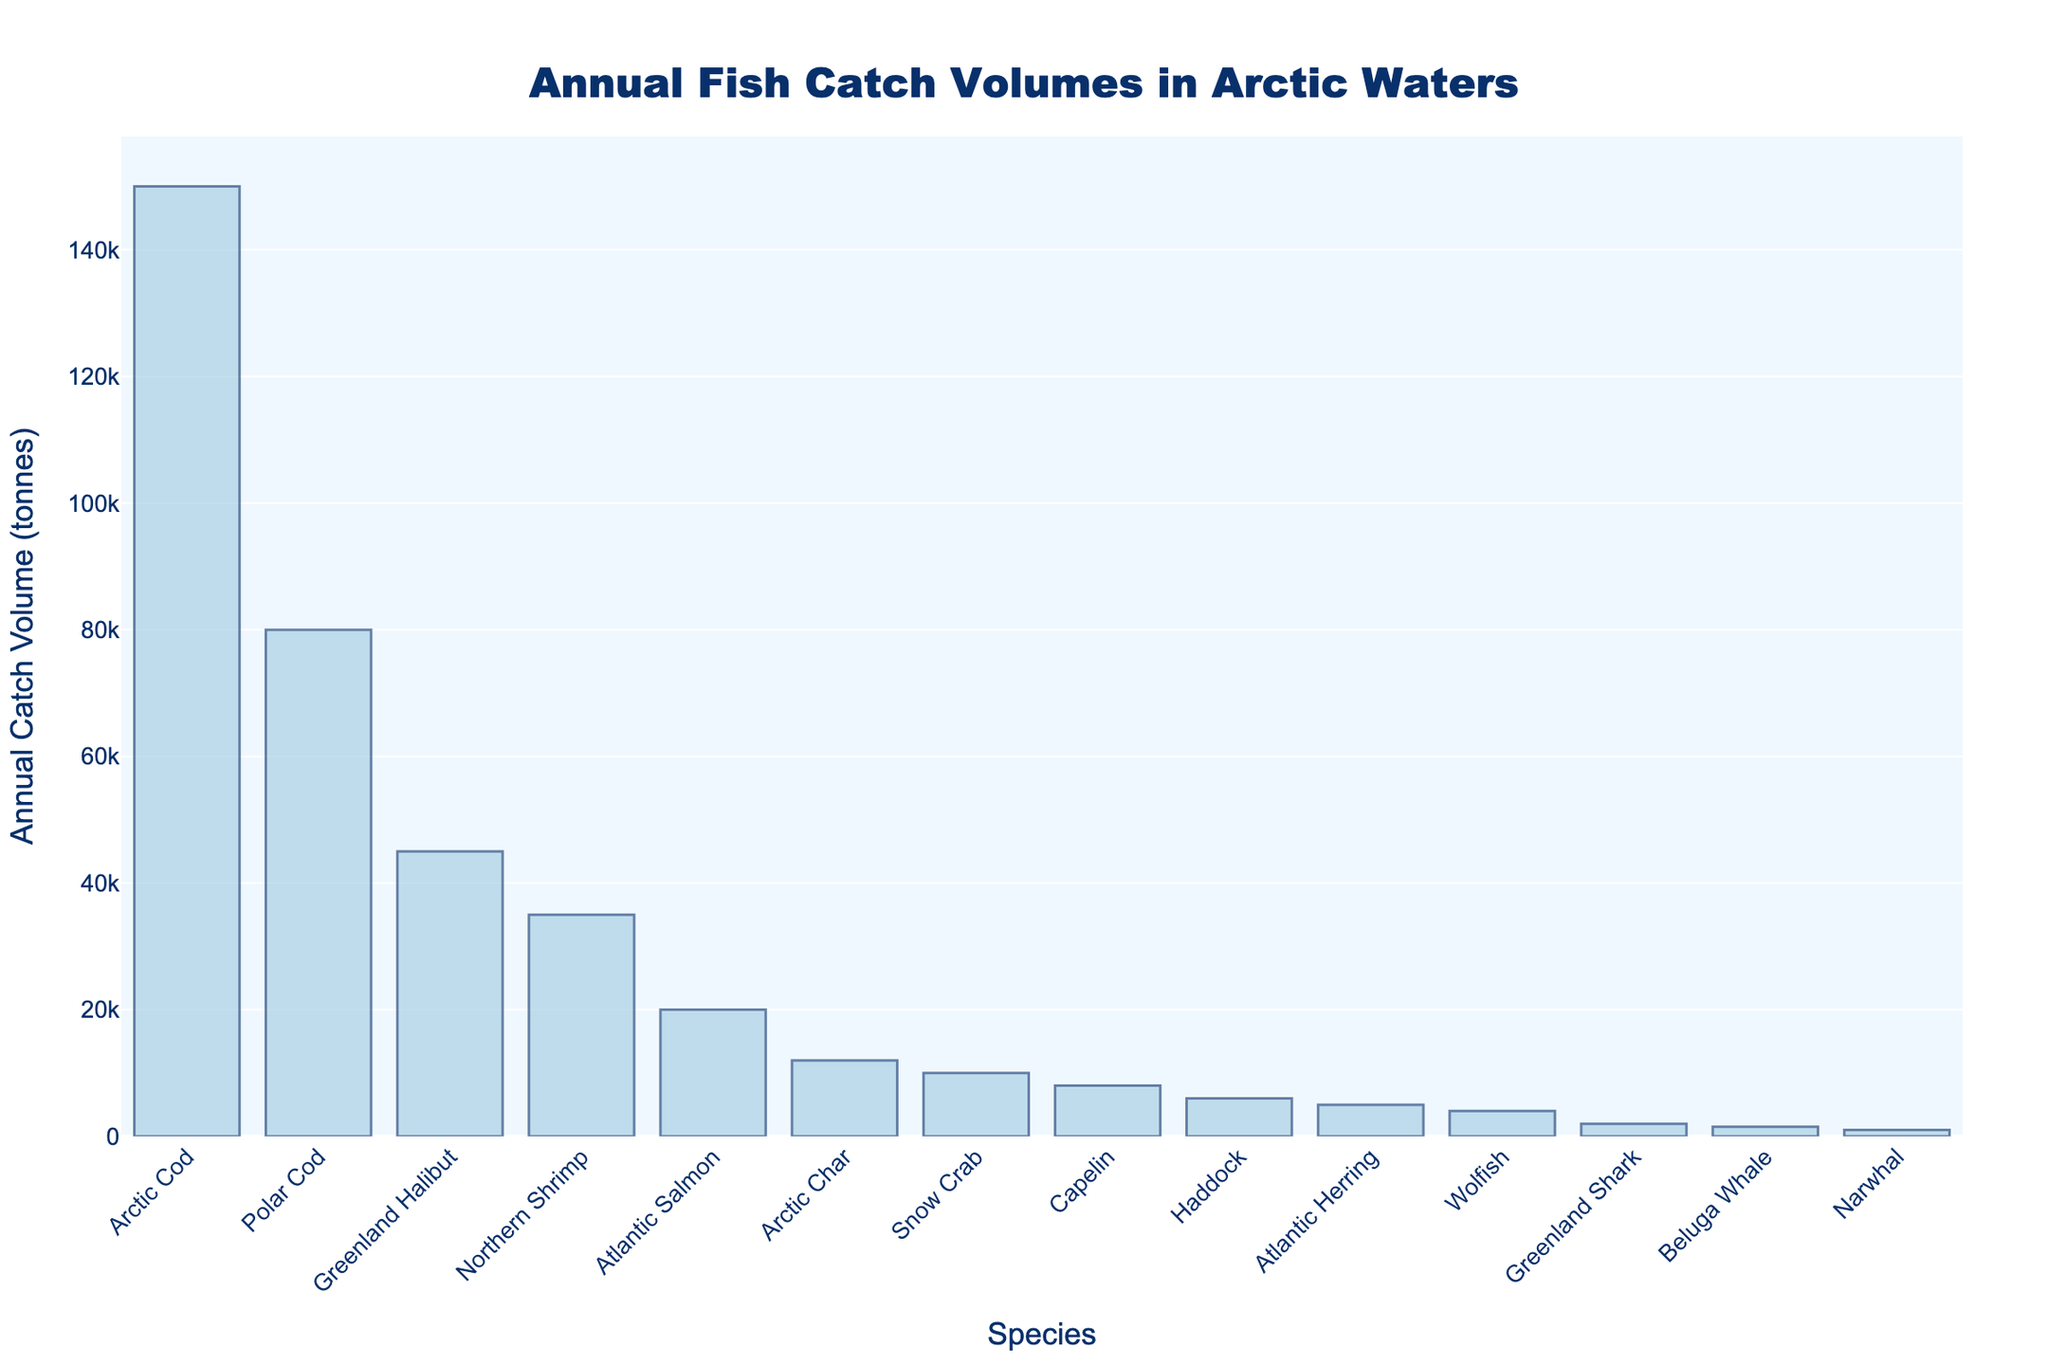Which species has the highest annual catch volume? The chart shows different species and their annual catch volumes in tonnes. The tallest bar represents the species with the highest catch volume.
Answer: Arctic Cod What is the difference in annual catch volume between Arctic Cod and Polar Cod? To find the difference, subtract the annual catch volume of Polar Cod from that of Arctic Cod (150,000 - 80,000).
Answer: 70,000 tonnes Which species has a lower annual catch volume, Narwhal or Beluga Whale? By comparing the heights of the bars for Narwhal and Beluga Whale, we see that the bar for Narwhal is shorter than that for Beluga Whale.
Answer: Narwhal What is the total annual catch volume for Greenland Halibut, Northern Shrimp, and Atlantic Salmon combined? Sum the catch volumes for these three species (45,000 + 35,000 + 20,000).
Answer: 100,000 tonnes How many species have an annual catch volume greater than 10,000 tonnes? Count the number of bars that represent species with catch volumes above 10,000 tonnes. 8 bars exceed this threshold: Arctic Cod, Polar Cod, Greenland Halibut, Northern Shrimp, Atlantic Salmon, Arctic Char, Snow Crab, and Capelin.
Answer: 8 species Which species has the smallest annual catch volume, and what is it? The shortest bar will represent the species with the smallest annual catch volume.
Answer: Narwhal, 1,000 tonnes Is the annual catch volume of Atlantic Herring closer to that of Haddock or Wolfish? Compare the heights of the bars for Haddock (6,000 tonnes), Atlantic Herring (5,000 tonnes), and Wolfish (4,000 tonnes). The bar for Atlantic Herring is visually closer in height to that of Haddock.
Answer: Haddock What is the average annual catch volume of Atlantic Herring, Wolfish, and Greenland Shark? To find the average, sum their catch volumes (5,000 + 4,000 + 2,000) and divide by 3. (11,000 ÷ 3).
Answer: Approximately 3,667 tonnes Which two species have the closest annual catch volumes and what is their difference? Comparing the heights of the bars, we observe that Beluga Whale (1,500 tonnes) and Narwhal (1,000 tonnes) have the closest volumes. Subtract 1,000 from 1,500.
Answer: Beluga Whale and Narwhal, 500 tonnes How does the annual catch volume of Northern Shrimp compare to that of Snow Crab? By comparing the bars, Northern Shrimp (35,000 tonnes) has a higher annual catch volume than Snow Crab (10,000 tonnes).
Answer: Northern Shrimp has a higher volume than Snow Crab 